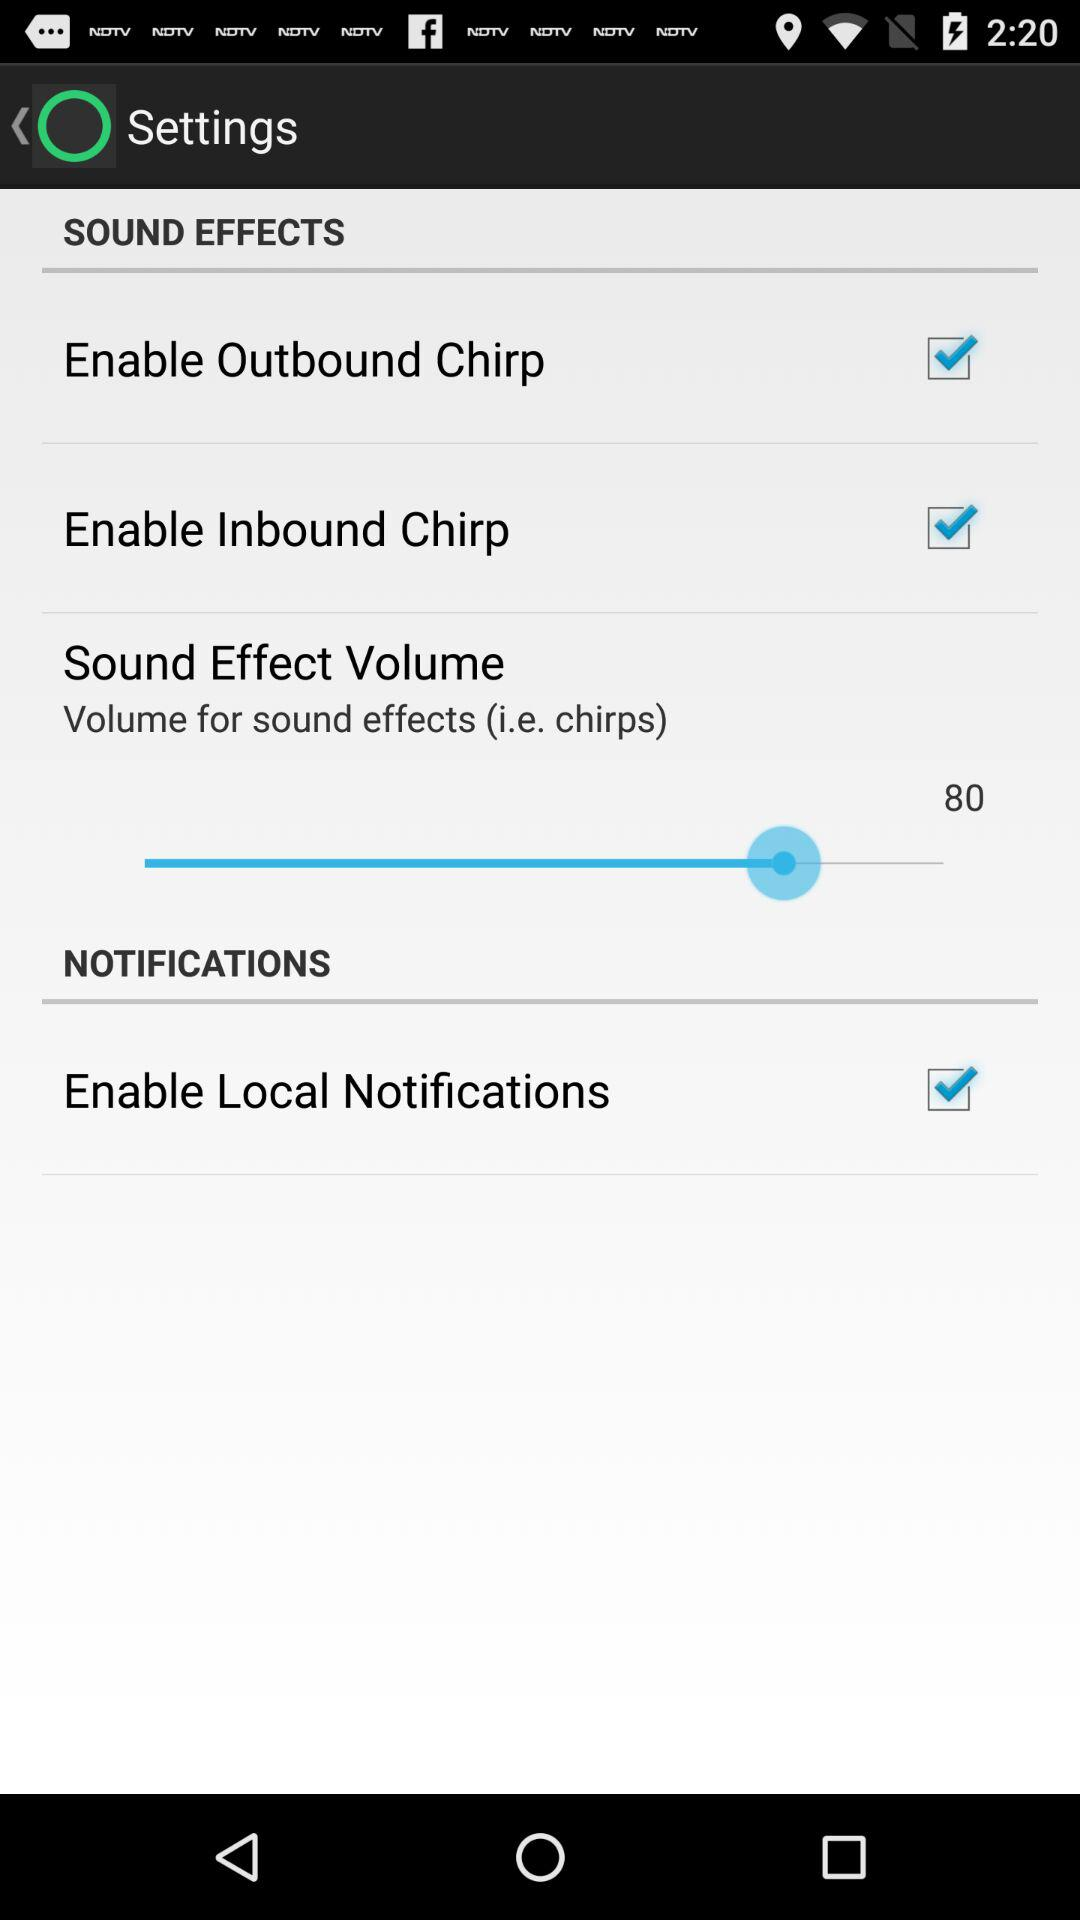What is the status of "Enable Inbound Chirp"? The status is "on". 